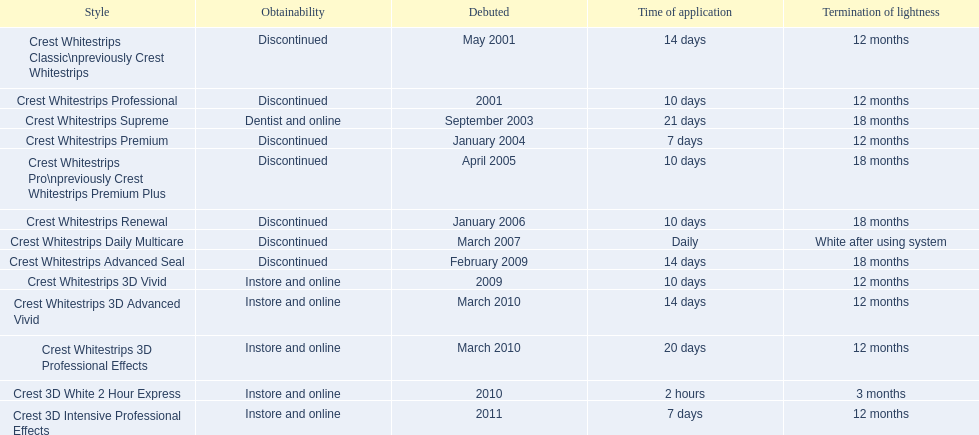What are all of the model names? Crest Whitestrips Classic\npreviously Crest Whitestrips, Crest Whitestrips Professional, Crest Whitestrips Supreme, Crest Whitestrips Premium, Crest Whitestrips Pro\npreviously Crest Whitestrips Premium Plus, Crest Whitestrips Renewal, Crest Whitestrips Daily Multicare, Crest Whitestrips Advanced Seal, Crest Whitestrips 3D Vivid, Crest Whitestrips 3D Advanced Vivid, Crest Whitestrips 3D Professional Effects, Crest 3D White 2 Hour Express, Crest 3D Intensive Professional Effects. When were they first introduced? May 2001, 2001, September 2003, January 2004, April 2005, January 2006, March 2007, February 2009, 2009, March 2010, March 2010, 2010, 2011. Along with crest whitestrips 3d advanced vivid, which other model was introduced in march 2010? Crest Whitestrips 3D Professional Effects. 